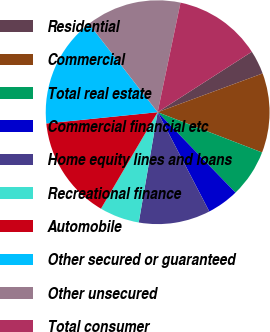Convert chart to OTSL. <chart><loc_0><loc_0><loc_500><loc_500><pie_chart><fcel>Residential<fcel>Commercial<fcel>Total real estate<fcel>Commercial financial etc<fcel>Home equity lines and loans<fcel>Recreational finance<fcel>Automobile<fcel>Other secured or guaranteed<fcel>Other unsecured<fcel>Total consumer<nl><fcel>3.45%<fcel>11.49%<fcel>6.9%<fcel>4.6%<fcel>10.34%<fcel>5.75%<fcel>14.94%<fcel>16.09%<fcel>13.79%<fcel>12.64%<nl></chart> 